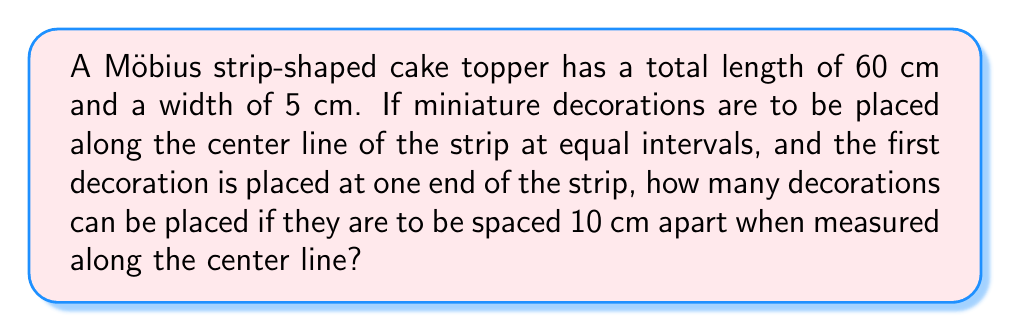Can you answer this question? Let's approach this step-by-step:

1) First, we need to understand the properties of a Möbius strip. A Möbius strip is a surface with only one side and one edge. If we travel along the center line, we will return to the starting point after traversing twice the length of the strip.

2) The total length of the center line of the Möbius strip is equal to the length of the strip itself, which is 60 cm.

3) We start placing decorations at one end, and we want them to be 10 cm apart. Let's count how many decorations we can place:

   - 1st decoration: at 0 cm
   - 2nd decoration: at 10 cm
   - 3rd decoration: at 20 cm
   - 4th decoration: at 30 cm
   - 5th decoration: at 40 cm
   - 6th decoration: at 50 cm

4) We might think we can place a 7th decoration at 60 cm, but this is actually the same point as 0 cm on a Möbius strip!

5) Therefore, we can place 6 decorations in total.

6) We can verify this mathematically:

   $$\text{Number of decorations} = \frac{\text{Length of strip}}{\text{Spacing}} = \frac{60 \text{ cm}}{10 \text{ cm}} = 6$$

This calculation confirms our step-by-step placement.
Answer: 6 decorations 